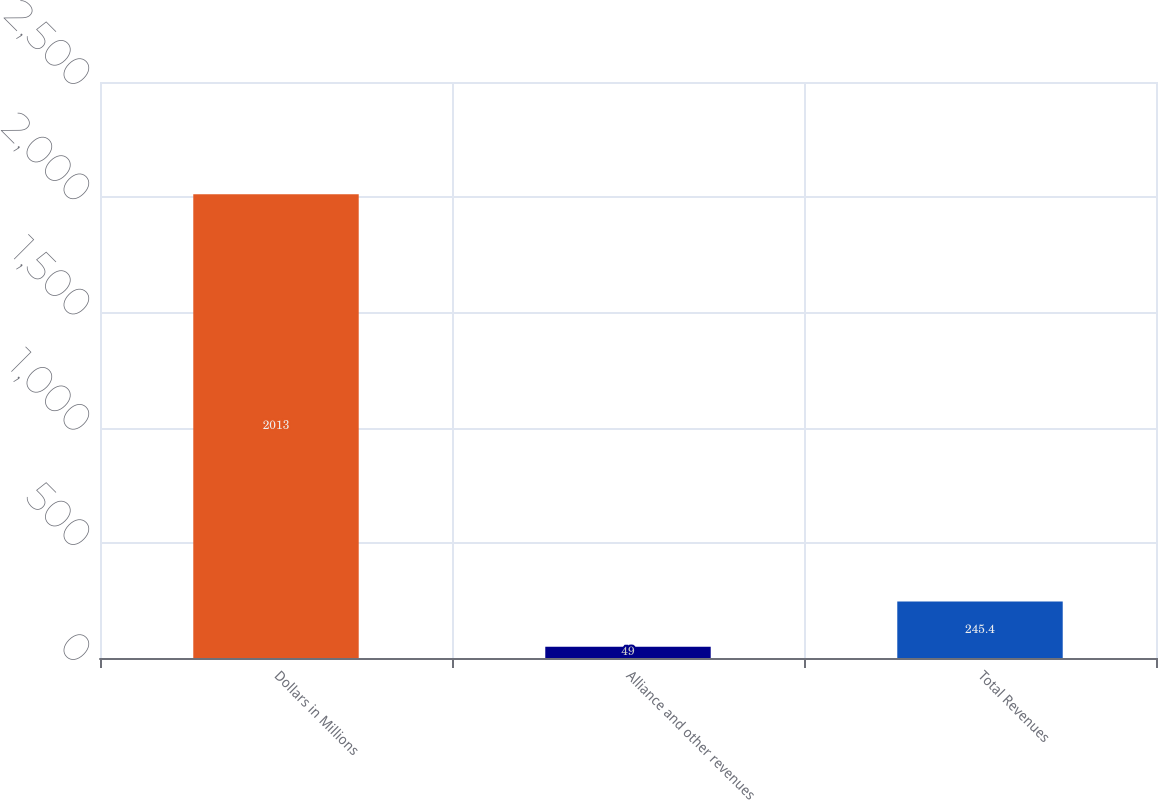Convert chart to OTSL. <chart><loc_0><loc_0><loc_500><loc_500><bar_chart><fcel>Dollars in Millions<fcel>Alliance and other revenues<fcel>Total Revenues<nl><fcel>2013<fcel>49<fcel>245.4<nl></chart> 